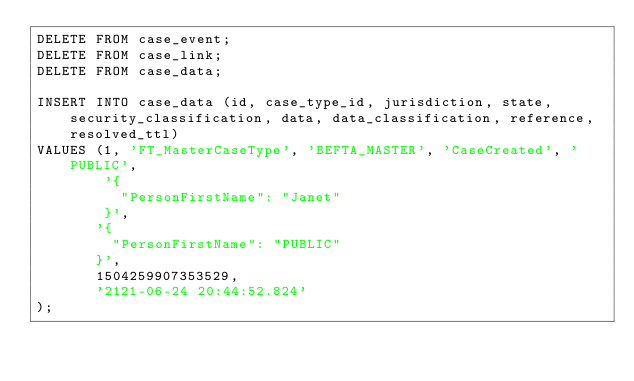<code> <loc_0><loc_0><loc_500><loc_500><_SQL_>DELETE FROM case_event;
DELETE FROM case_link;
DELETE FROM case_data;

INSERT INTO case_data (id, case_type_id, jurisdiction, state, security_classification, data, data_classification, reference, resolved_ttl)
VALUES (1, 'FT_MasterCaseType', 'BEFTA_MASTER', 'CaseCreated', 'PUBLIC',
        '{
          "PersonFirstName": "Janet"
        }',
       '{
         "PersonFirstName": "PUBLIC"
       }',
       1504259907353529,
       '2121-06-24 20:44:52.824'
);
</code> 